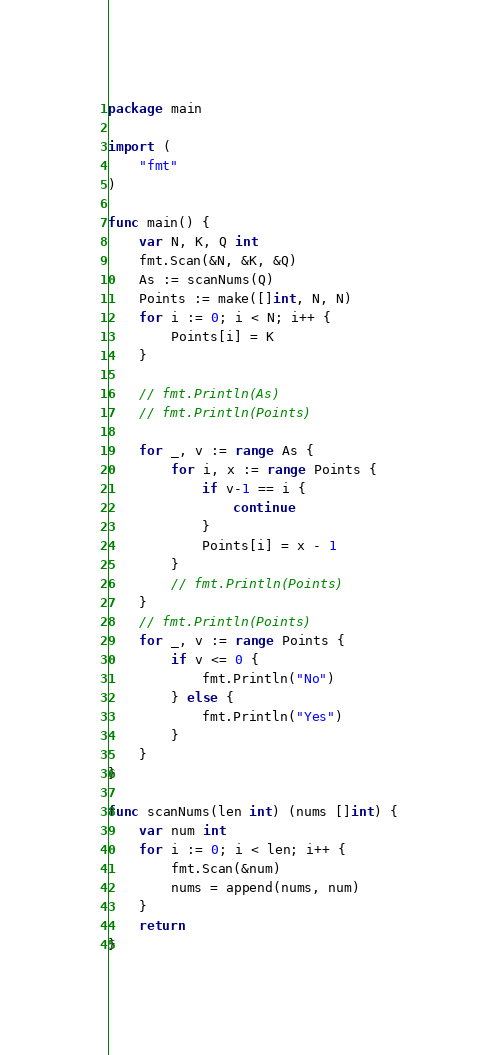<code> <loc_0><loc_0><loc_500><loc_500><_Go_>package main

import (
	"fmt"
)

func main() {
	var N, K, Q int
	fmt.Scan(&N, &K, &Q)
	As := scanNums(Q)
	Points := make([]int, N, N)
	for i := 0; i < N; i++ {
		Points[i] = K
	}

	// fmt.Println(As)
	// fmt.Println(Points)

	for _, v := range As {
		for i, x := range Points {
			if v-1 == i {
				continue
			}
			Points[i] = x - 1
		}
		// fmt.Println(Points)
	}
	// fmt.Println(Points)
	for _, v := range Points {
		if v <= 0 {
			fmt.Println("No")
		} else {
			fmt.Println("Yes")
		}
	}
}

func scanNums(len int) (nums []int) {
	var num int
	for i := 0; i < len; i++ {
		fmt.Scan(&num)
		nums = append(nums, num)
	}
	return
}
</code> 